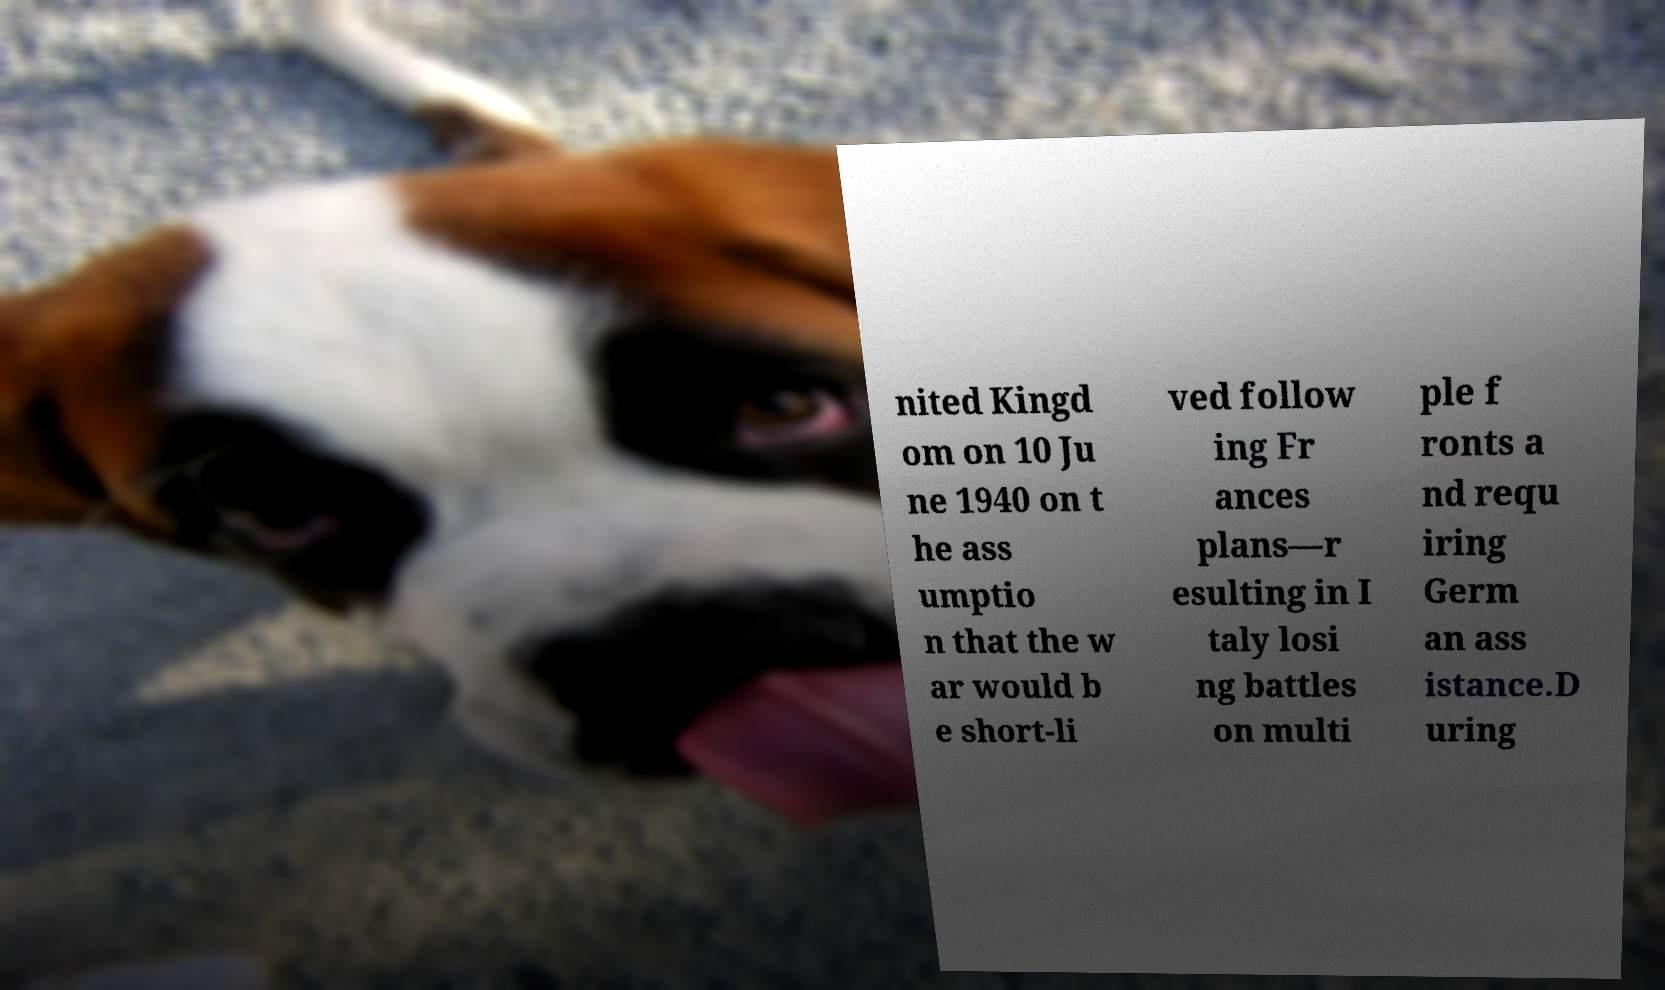Can you accurately transcribe the text from the provided image for me? nited Kingd om on 10 Ju ne 1940 on t he ass umptio n that the w ar would b e short-li ved follow ing Fr ances plans—r esulting in I taly losi ng battles on multi ple f ronts a nd requ iring Germ an ass istance.D uring 